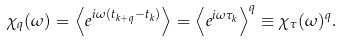<formula> <loc_0><loc_0><loc_500><loc_500>\chi _ { q } ( \omega ) = \left \langle e ^ { i \omega ( t _ { k + q } - t _ { k } ) } \right \rangle = \left \langle e ^ { i \omega \tau _ { k } } \right \rangle ^ { q } \equiv \chi _ { \tau } ( \omega ) ^ { q } .</formula> 